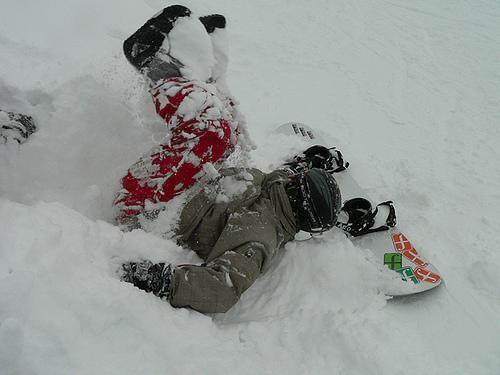How many people are in the picture?
Give a very brief answer. 1. 